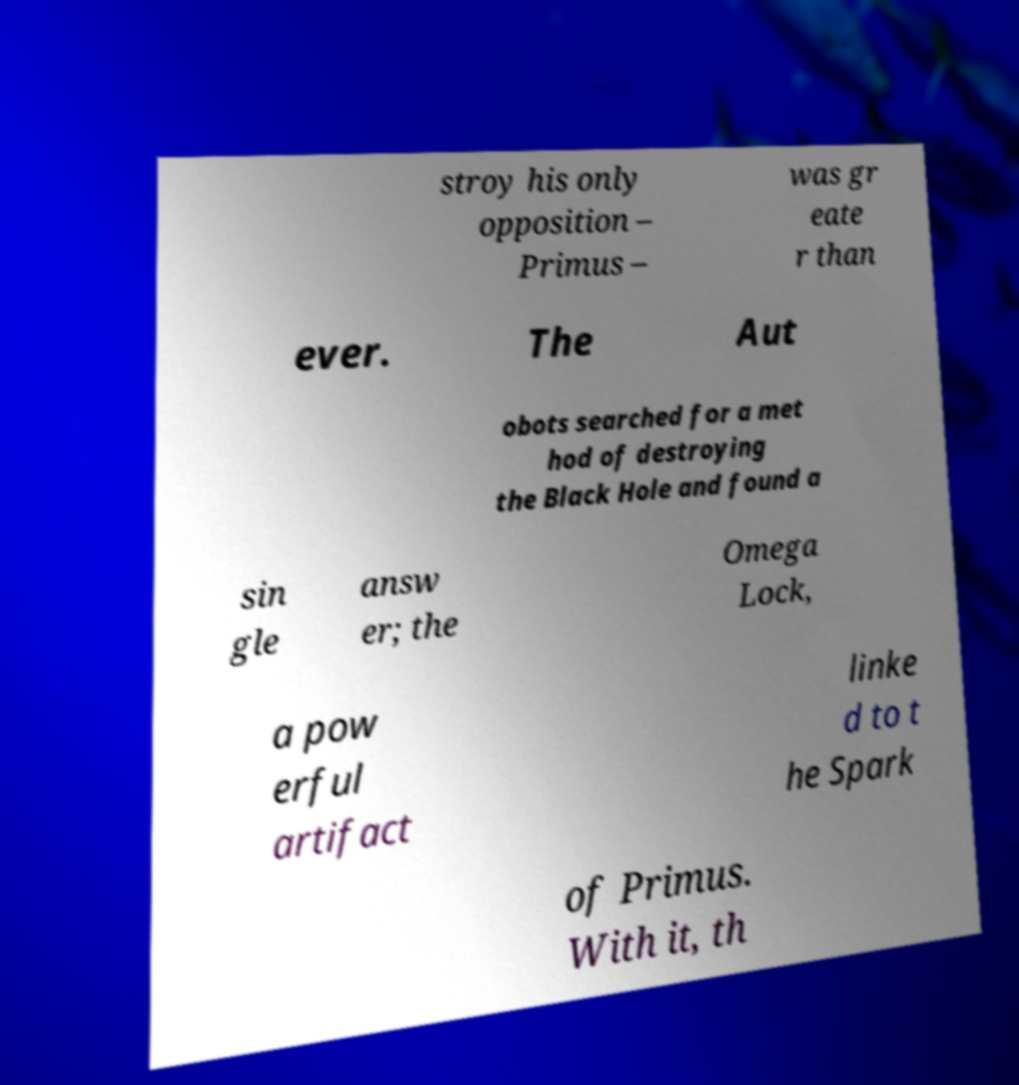Please read and relay the text visible in this image. What does it say? stroy his only opposition – Primus – was gr eate r than ever. The Aut obots searched for a met hod of destroying the Black Hole and found a sin gle answ er; the Omega Lock, a pow erful artifact linke d to t he Spark of Primus. With it, th 